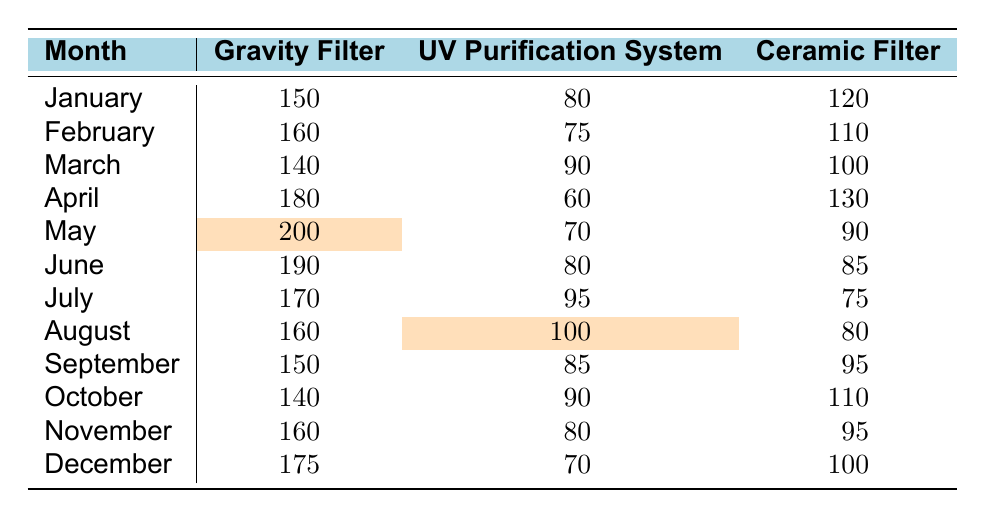What was the inventory of Gravity Filters in May? In May, the inventory level for Gravity Filters is highlighted in the table, showing a value of 200.
Answer: 200 Which month had the highest inventory of UV Purification Systems? The highest inventory for UV Purification Systems is in August with a value of 100.
Answer: August What was the average inventory of Ceramic Filters from January to March? The total inventory for Ceramic Filters from January to March is (120 + 110 + 100) = 330, and there are 3 months. So, the average is 330/3 = 110.
Answer: 110 Is the inventory of UV Purification Systems in April lower than in June? April's inventory is 60 while June's is 80; since 60 < 80, this statement is true.
Answer: Yes Calculate the total inventory of Gravity Filters from April to December. The monthly inventories for Gravity Filters from April to December are (180 + 200 + 190 + 170 + 160 + 150 + 140 + 160 + 175). The total is 180 + 200 + 190 + 170 + 160 + 150 + 140 + 160 + 175 = 1375.
Answer: 1375 Which product had the lowest inventory in July? In July, the inventory levels are 170 for Gravity Filters, 95 for UV Purification Systems, and 75 for Ceramic Filters. The lowest value is 75 for Ceramic Filters.
Answer: Ceramic Filter Was there a decrease in inventory for any type of filter from February to March? Comparing February (160 Gravity, 75 UV, 110 Ceramic) to March (140 Gravity, 90 UV, 100 Ceramic), Gravity Filters decreased from 160 to 140, yes, so there was a decrease.
Answer: Yes What is the difference in inventory of UV Purification Systems between October and December? The inventory for UV Purification Systems is 90 in October and 70 in December. The difference is 90 - 70 = 20.
Answer: 20 During which month did Ceramic Filters reach their highest inventory? Looking at all months for Ceramic Filters, the highest value is 130 in April.
Answer: April What is the total inventory for all types of filters in June? For June, the inventories are 190 (Gravity) + 80 (UV) + 85 (Ceramic) = 190 + 80 + 85 = 355.
Answer: 355 